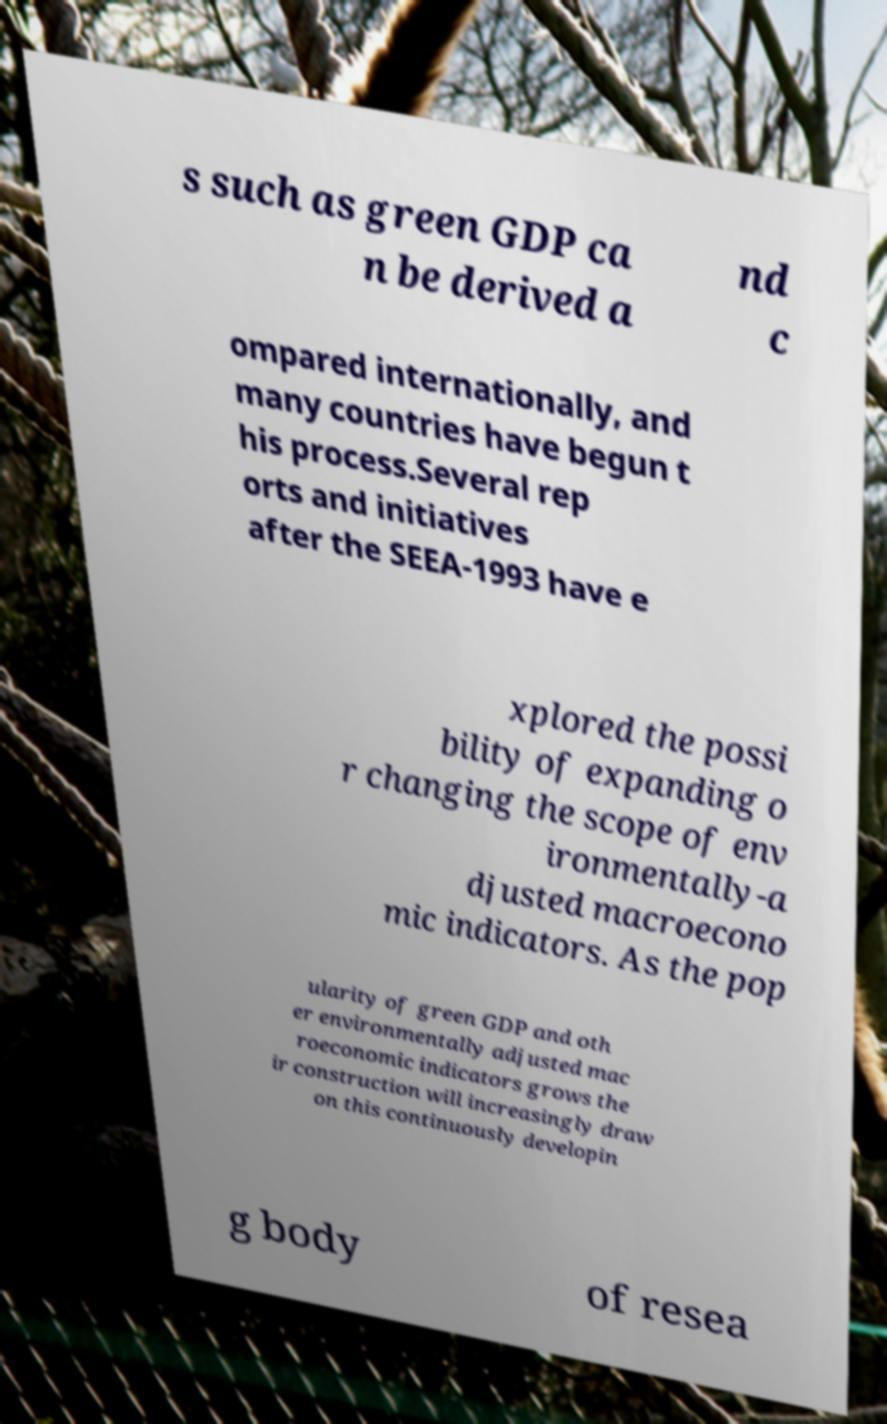For documentation purposes, I need the text within this image transcribed. Could you provide that? s such as green GDP ca n be derived a nd c ompared internationally, and many countries have begun t his process.Several rep orts and initiatives after the SEEA-1993 have e xplored the possi bility of expanding o r changing the scope of env ironmentally-a djusted macroecono mic indicators. As the pop ularity of green GDP and oth er environmentally adjusted mac roeconomic indicators grows the ir construction will increasingly draw on this continuously developin g body of resea 